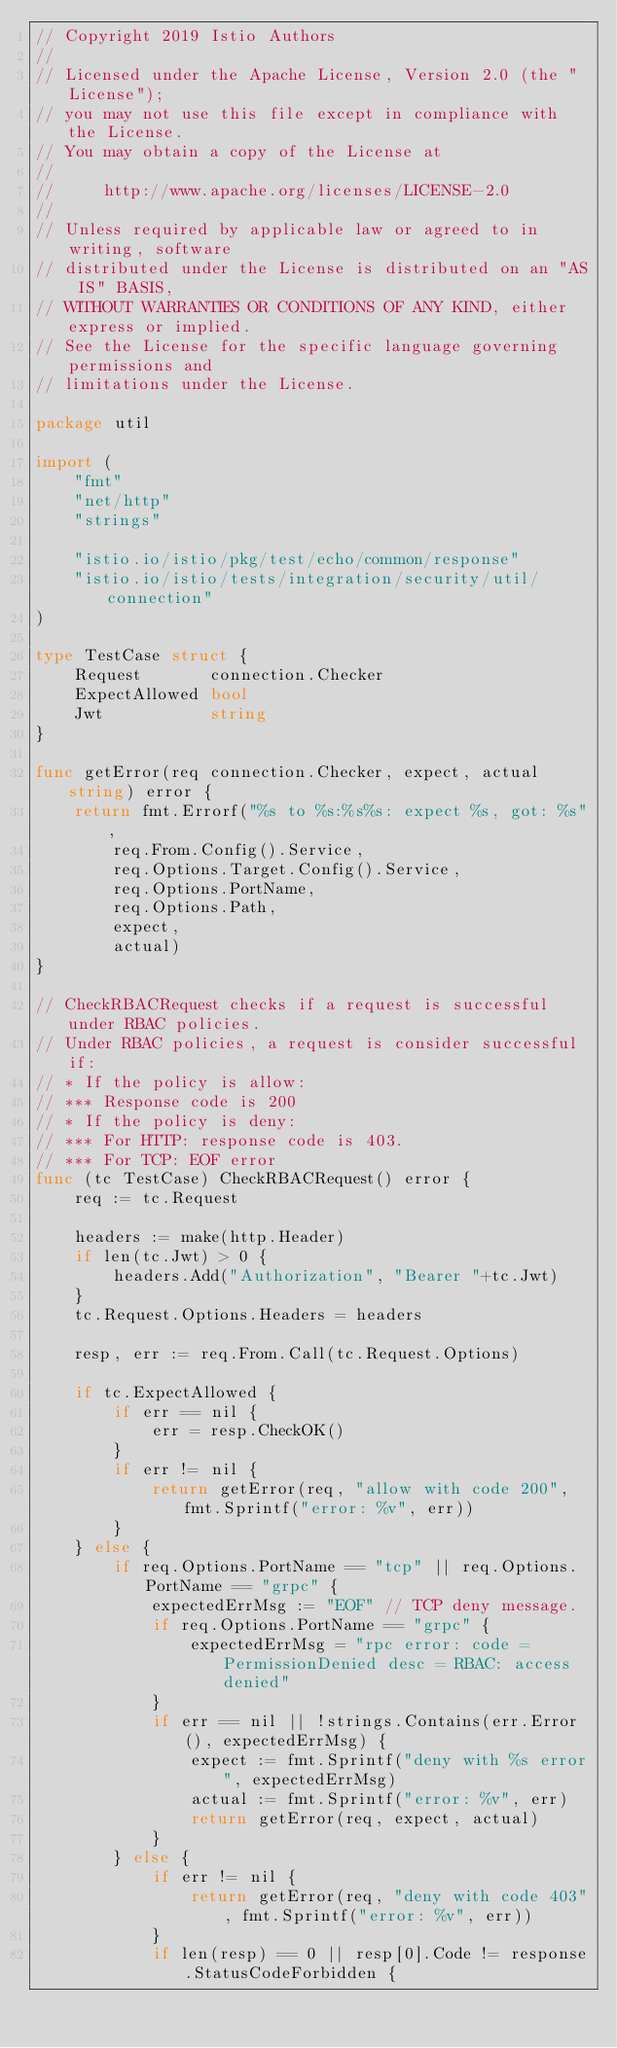Convert code to text. <code><loc_0><loc_0><loc_500><loc_500><_Go_>// Copyright 2019 Istio Authors
//
// Licensed under the Apache License, Version 2.0 (the "License");
// you may not use this file except in compliance with the License.
// You may obtain a copy of the License at
//
//     http://www.apache.org/licenses/LICENSE-2.0
//
// Unless required by applicable law or agreed to in writing, software
// distributed under the License is distributed on an "AS IS" BASIS,
// WITHOUT WARRANTIES OR CONDITIONS OF ANY KIND, either express or implied.
// See the License for the specific language governing permissions and
// limitations under the License.

package util

import (
	"fmt"
	"net/http"
	"strings"

	"istio.io/istio/pkg/test/echo/common/response"
	"istio.io/istio/tests/integration/security/util/connection"
)

type TestCase struct {
	Request       connection.Checker
	ExpectAllowed bool
	Jwt           string
}

func getError(req connection.Checker, expect, actual string) error {
	return fmt.Errorf("%s to %s:%s%s: expect %s, got: %s",
		req.From.Config().Service,
		req.Options.Target.Config().Service,
		req.Options.PortName,
		req.Options.Path,
		expect,
		actual)
}

// CheckRBACRequest checks if a request is successful under RBAC policies.
// Under RBAC policies, a request is consider successful if:
// * If the policy is allow:
// *** Response code is 200
// * If the policy is deny:
// *** For HTTP: response code is 403.
// *** For TCP: EOF error
func (tc TestCase) CheckRBACRequest() error {
	req := tc.Request

	headers := make(http.Header)
	if len(tc.Jwt) > 0 {
		headers.Add("Authorization", "Bearer "+tc.Jwt)
	}
	tc.Request.Options.Headers = headers

	resp, err := req.From.Call(tc.Request.Options)

	if tc.ExpectAllowed {
		if err == nil {
			err = resp.CheckOK()
		}
		if err != nil {
			return getError(req, "allow with code 200", fmt.Sprintf("error: %v", err))
		}
	} else {
		if req.Options.PortName == "tcp" || req.Options.PortName == "grpc" {
			expectedErrMsg := "EOF" // TCP deny message.
			if req.Options.PortName == "grpc" {
				expectedErrMsg = "rpc error: code = PermissionDenied desc = RBAC: access denied"
			}
			if err == nil || !strings.Contains(err.Error(), expectedErrMsg) {
				expect := fmt.Sprintf("deny with %s error", expectedErrMsg)
				actual := fmt.Sprintf("error: %v", err)
				return getError(req, expect, actual)
			}
		} else {
			if err != nil {
				return getError(req, "deny with code 403", fmt.Sprintf("error: %v", err))
			}
			if len(resp) == 0 || resp[0].Code != response.StatusCodeForbidden {</code> 